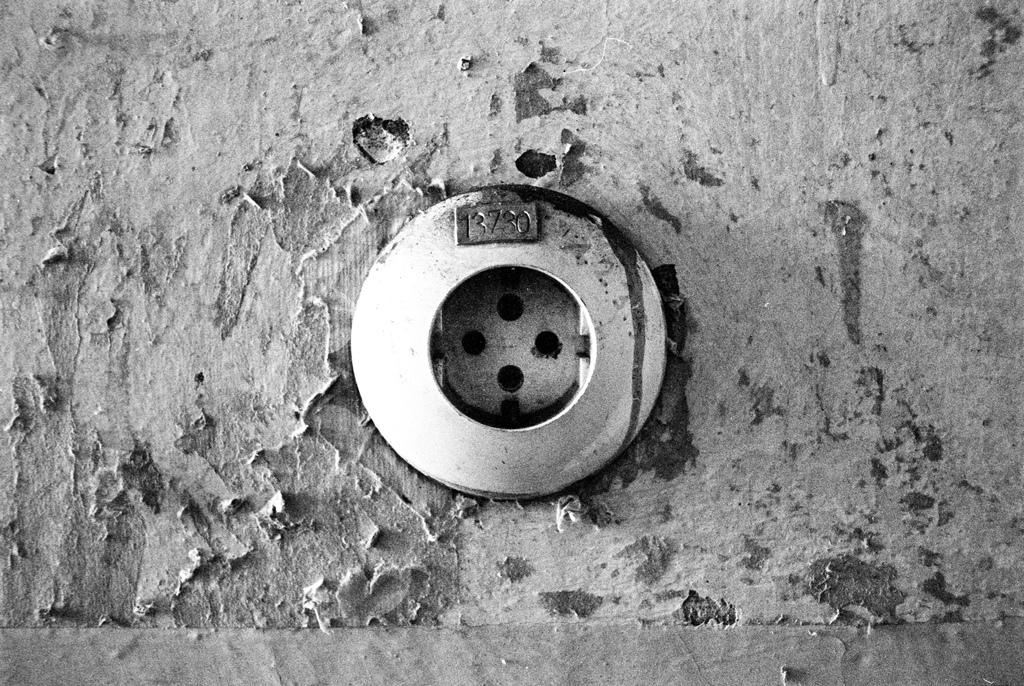Provide a one-sentence caption for the provided image. A picture of a drain with the number 13730. 